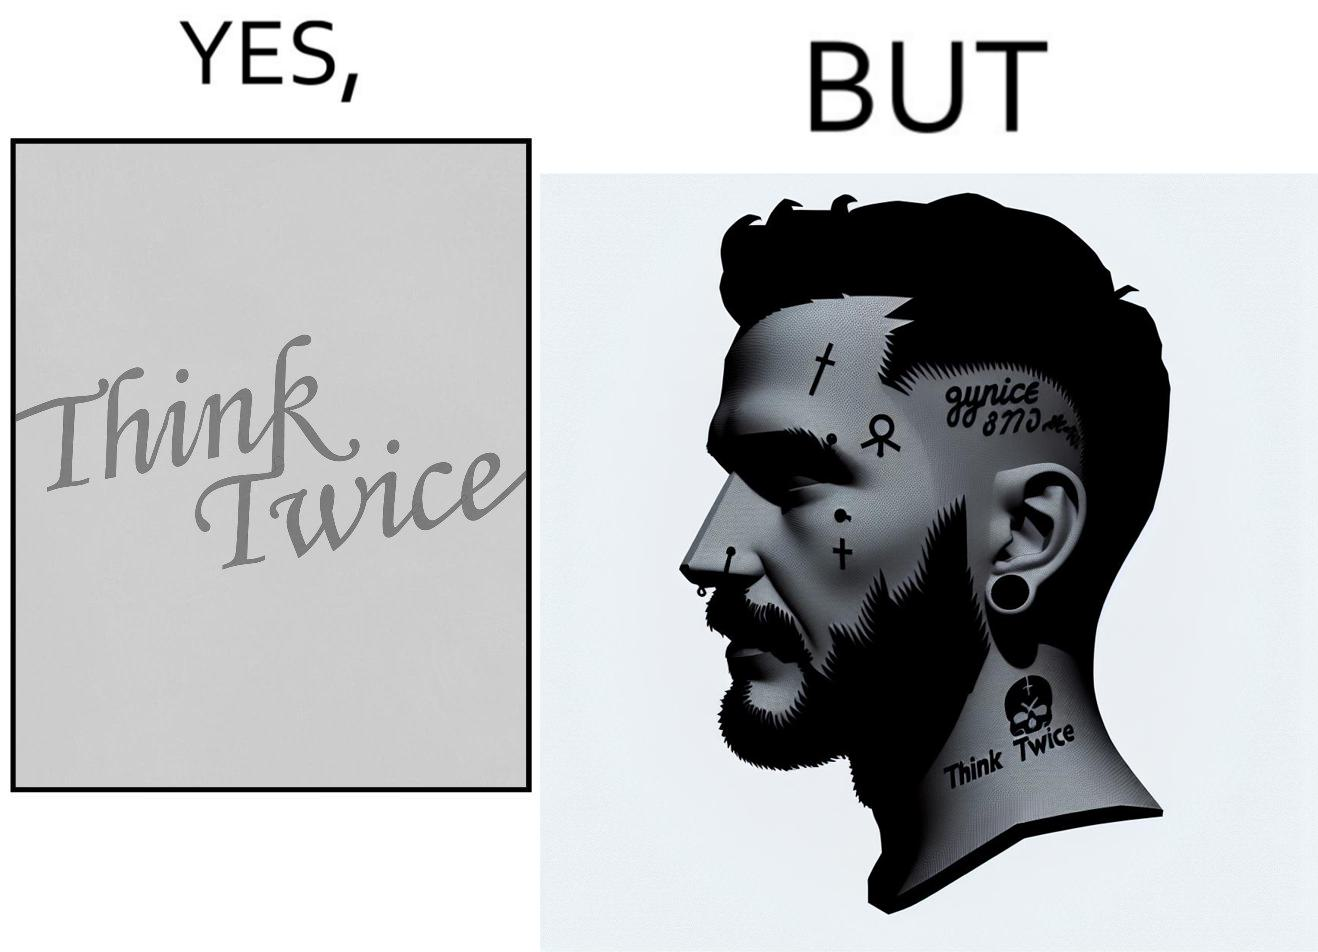What is shown in this image? The image is funny because even thought the tattoo on the face of the man says "think twice", the man did not think twice before getting the tattoo on his forehead. 